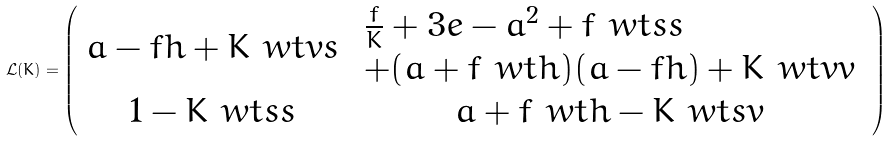Convert formula to latex. <formula><loc_0><loc_0><loc_500><loc_500>\mathcal { L } ( K ) = \left ( \begin{array} { c c } a - f h + K \ w t { v } s & \begin{array} { l } \frac { f } { K } + 3 e - a ^ { 2 } + f \ w t { s } s \\ + ( a + f \ w t { h } ) ( a - f h ) + K \ w t { v } v \end{array} \\ 1 - K \ w t { s } s & a + f \ w t { h } - K \ w t { s } v \end{array} \right )</formula> 